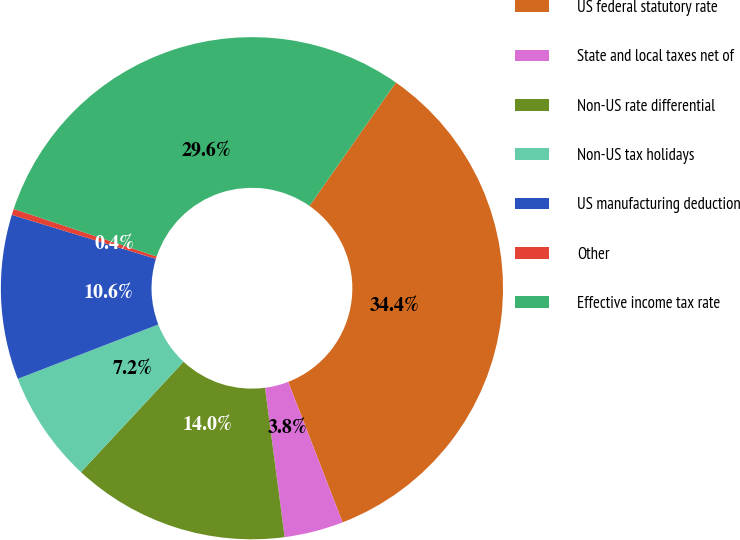Convert chart. <chart><loc_0><loc_0><loc_500><loc_500><pie_chart><fcel>US federal statutory rate<fcel>State and local taxes net of<fcel>Non-US rate differential<fcel>Non-US tax holidays<fcel>US manufacturing deduction<fcel>Other<fcel>Effective income tax rate<nl><fcel>34.41%<fcel>3.8%<fcel>14.0%<fcel>7.2%<fcel>10.6%<fcel>0.39%<fcel>29.6%<nl></chart> 